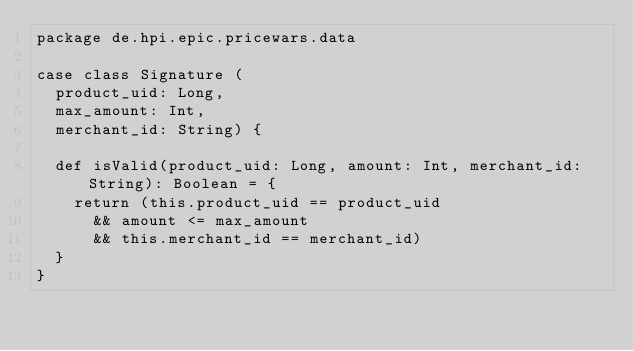<code> <loc_0><loc_0><loc_500><loc_500><_Scala_>package de.hpi.epic.pricewars.data

case class Signature (
  product_uid: Long,
  max_amount: Int,
  merchant_id: String) {

  def isValid(product_uid: Long, amount: Int, merchant_id: String): Boolean = {
    return (this.product_uid == product_uid
      && amount <= max_amount
      && this.merchant_id == merchant_id)
  }
}
</code> 